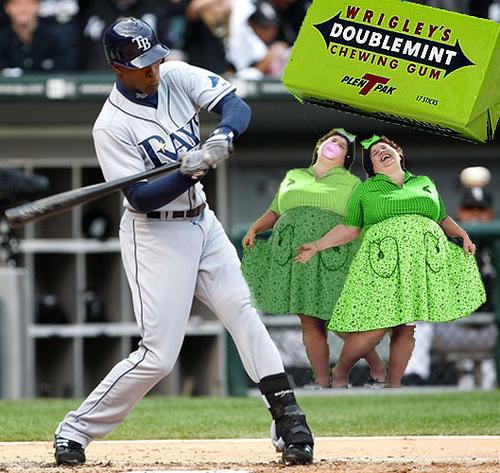What type of gum are they showing?
Concise answer only. Wrigley's. What color dress are the woman wearing?
Keep it brief. Green. What team is the batter on?
Keep it brief. Rays. What team is he on?
Answer briefly. Rays. 